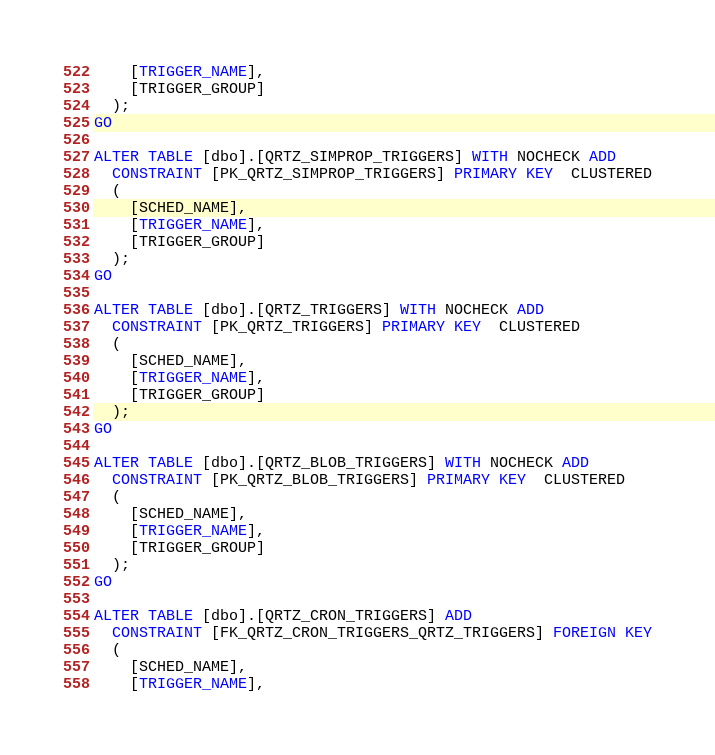Convert code to text. <code><loc_0><loc_0><loc_500><loc_500><_SQL_>    [TRIGGER_NAME],
    [TRIGGER_GROUP]
  );
GO

ALTER TABLE [dbo].[QRTZ_SIMPROP_TRIGGERS] WITH NOCHECK ADD
  CONSTRAINT [PK_QRTZ_SIMPROP_TRIGGERS] PRIMARY KEY  CLUSTERED
  (
    [SCHED_NAME],
    [TRIGGER_NAME],
    [TRIGGER_GROUP]
  );
GO

ALTER TABLE [dbo].[QRTZ_TRIGGERS] WITH NOCHECK ADD
  CONSTRAINT [PK_QRTZ_TRIGGERS] PRIMARY KEY  CLUSTERED
  (
    [SCHED_NAME],
    [TRIGGER_NAME],
    [TRIGGER_GROUP]
  );
GO

ALTER TABLE [dbo].[QRTZ_BLOB_TRIGGERS] WITH NOCHECK ADD
  CONSTRAINT [PK_QRTZ_BLOB_TRIGGERS] PRIMARY KEY  CLUSTERED
  (
    [SCHED_NAME],
    [TRIGGER_NAME],
    [TRIGGER_GROUP]
  );
GO

ALTER TABLE [dbo].[QRTZ_CRON_TRIGGERS] ADD
  CONSTRAINT [FK_QRTZ_CRON_TRIGGERS_QRTZ_TRIGGERS] FOREIGN KEY
  (
    [SCHED_NAME],
    [TRIGGER_NAME],</code> 